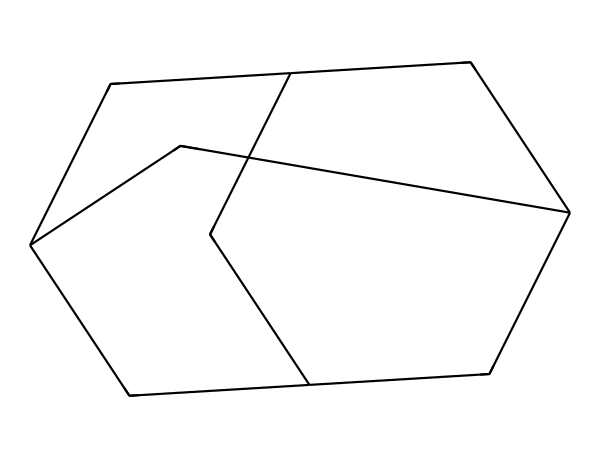How many carbon atoms are in adamantane? The SMILES representation shows multiple 'C' characters, and counting them gives us a total of 10 carbon atoms.
Answer: 10 What is the molecular formula of adamantane? From the structural representation, we count 10 carbons and 16 hydrogens, leading to the molecular formula C10H16.
Answer: C10H16 Does adamantane have any rings in its structure? Analyzing the structure, it is evident that adamantane is a polycyclic compound, having three interconnected cyclohexane-like rings.
Answer: Yes What is the main feature of cage compounds represented by adamantane? The structure demonstrates a three-dimensional arrangement where carbon atoms form a rigid, cage-like framework. This characteristic defines cage compounds.
Answer: Rigid framework How many unique hydrogen environments are present in adamantane? Looking closely at the molecular structure, there are distinct hydrogen atoms that can be categorized into two unique environments due to symmetry, leading to different chemical shifts in NMR spectroscopy.
Answer: 2 What kind of isomerism can adamantane exhibit? Given its structure, adamantane can exhibit stereoisomerism due to its rigid framework which might restrict rotation around certain bonds, leading to different spatial arrangements.
Answer: Stereoisomerism 